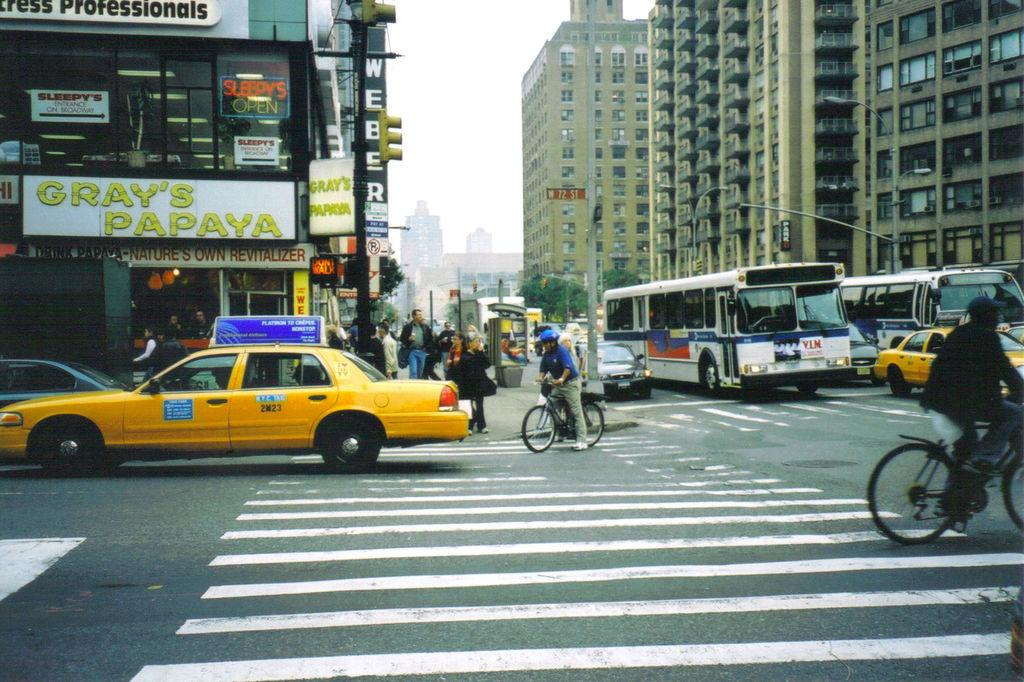Provide a one-sentence caption for the provided image. A yellow cab crosses an intersection below a sign that says Gray's Papaya. 